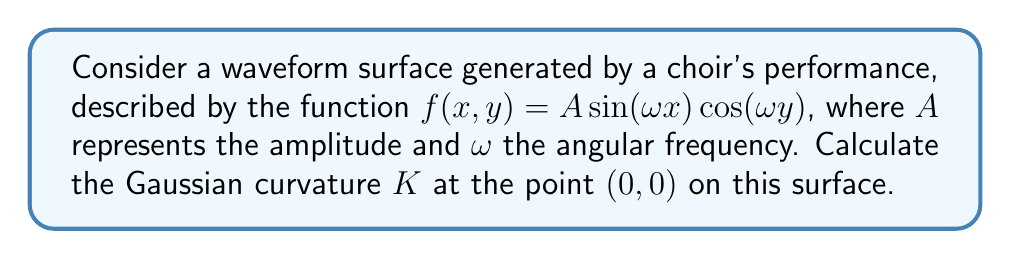Can you solve this math problem? To find the Gaussian curvature, we need to calculate the components of the curvature tensor and then use them to determine $K$. Let's proceed step-by-step:

1) First, we need to calculate the first and second partial derivatives of $f(x,y)$:

   $f_x = A\omega \cos(\omega x) \cos(\omega y)$
   $f_y = -A\omega \sin(\omega x) \sin(\omega y)$
   $f_{xx} = -A\omega^2 \sin(\omega x) \cos(\omega y)$
   $f_{yy} = -A\omega^2 \sin(\omega x) \cos(\omega y)$
   $f_{xy} = -A\omega^2 \cos(\omega x) \sin(\omega y)$

2) At the point $(0,0)$, these evaluate to:

   $f_x(0,0) = A\omega$
   $f_y(0,0) = 0$
   $f_{xx}(0,0) = 0$
   $f_{yy}(0,0) = 0$
   $f_{xy}(0,0) = 0$

3) The first fundamental form coefficients are:

   $E = 1 + f_x^2 = 1 + A^2\omega^2$
   $F = f_x f_y = 0$
   $G = 1 + f_y^2 = 1$

4) The second fundamental form coefficients are:

   $L = \frac{f_{xx}}{\sqrt{1+f_x^2+f_y^2}} = 0$
   $M = \frac{f_{xy}}{\sqrt{1+f_x^2+f_y^2}} = 0$
   $N = \frac{f_{yy}}{\sqrt{1+f_x^2+f_y^2}} = 0$

5) The Gaussian curvature is given by:

   $$K = \frac{LN - M^2}{EG - F^2}$$

6) Substituting the values:

   $$K = \frac{0 \cdot 0 - 0^2}{(1 + A^2\omega^2) \cdot 1 - 0^2} = 0$$

Therefore, the Gaussian curvature at $(0,0)$ is 0.
Answer: $K = 0$ 